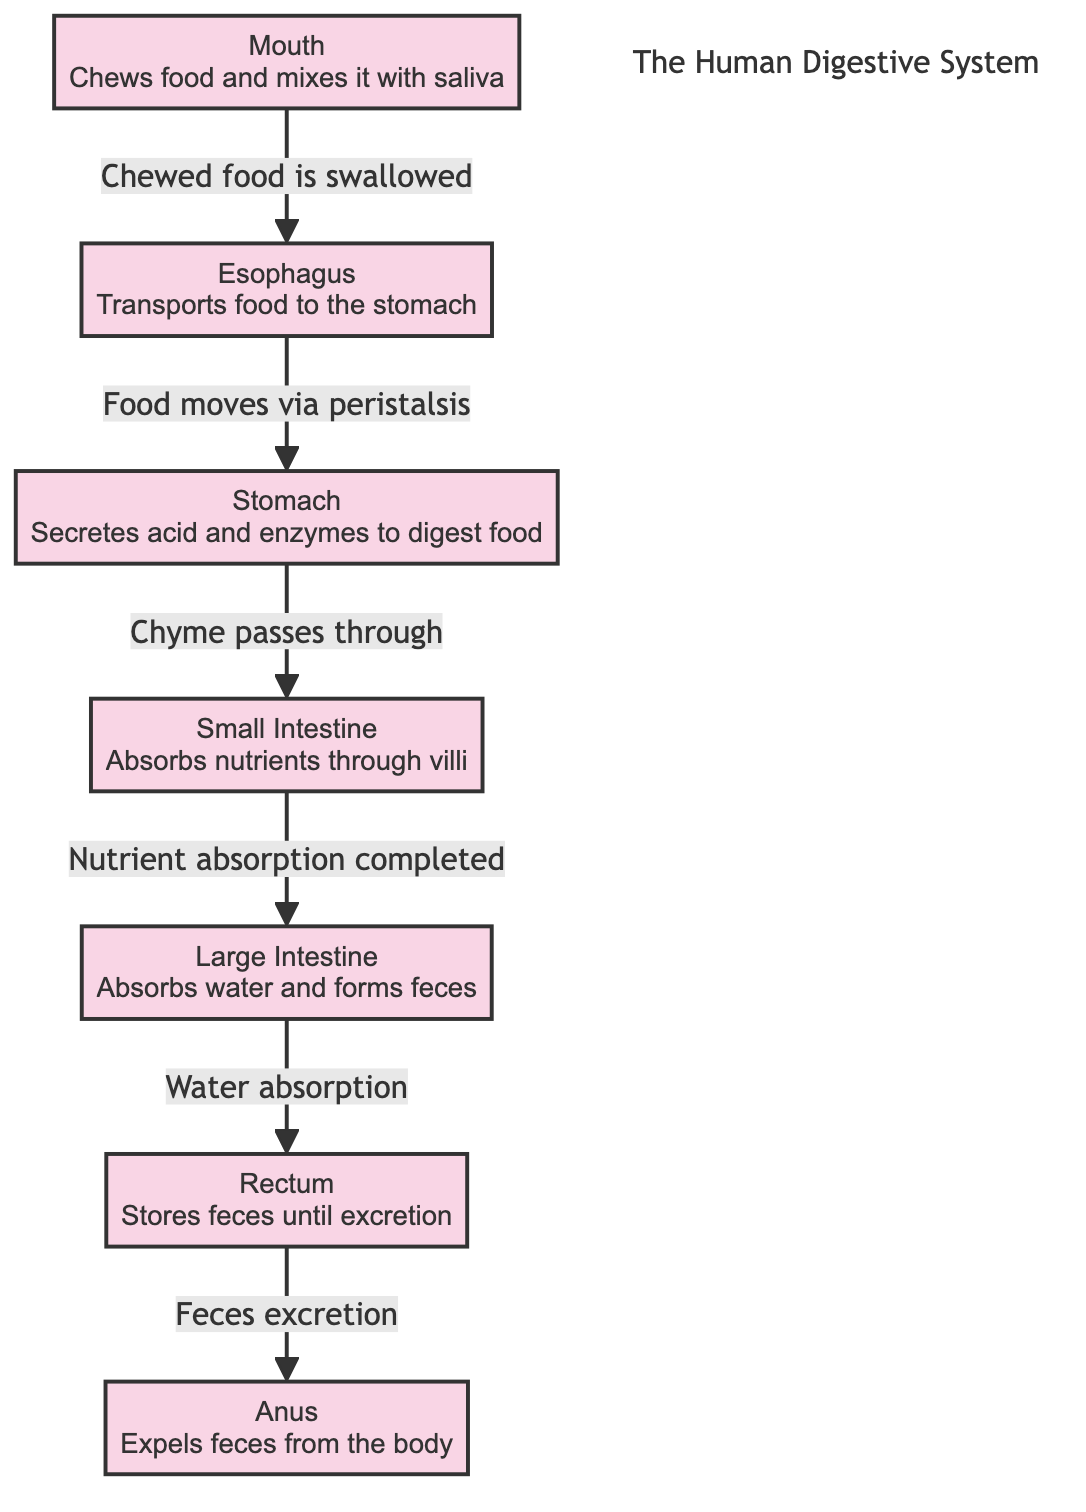What is the first organ in the digestive pathway? The diagram shows that food starts in the mouth, which is the first organ in the digestive process.
Answer: Mouth How many main organs are involved in the digestive system according to the diagram? By counting the labeled organs in the diagram, we see that there are six main organs: mouth, esophagus, stomach, small intestine, large intestine, rectum, and anus.
Answer: Six What process occurs in the esophagus? The diagram indicates that the esophagus transports food to the stomach and that this movement occurs via peristalsis.
Answer: Peristalsis Which organ absorbs water and forms feces? According to the diagram, the large intestine is responsible for absorbing water and forming feces.
Answer: Large Intestine What is the role of the stomach in digestion? The diagram states that the stomach secretes acid and enzymes to digest food, indicating its critical role in breaking down food substances.
Answer: Secretes acid and enzymes Trace the flow of food from the mouth to the anus. Looking at the diagram, food travels from the mouth to the esophagus (via swallowing), then to the stomach (via peristalsis), then to the small intestine (as chyme passes), followed by the large intestine (water absorption), rectum (storage of feces), and finally out of the anus (excretion). The sequential flow encapsulates the entire digestive process.
Answer: Mouth → Esophagus → Stomach → Small Intestine → Large Intestine → Rectum → Anus What nutrient absorption occurs in the small intestine? The diagram describes that the small intestine absorbs nutrients through villi, which are tiny hair-like structures that increase surface area for absorption.
Answer: Nutrients Which organ follows the stomach in the digestive pathway? From the diagram, it can be seen that food moves from the stomach to the small intestine as part of the digestive process.
Answer: Small Intestine 